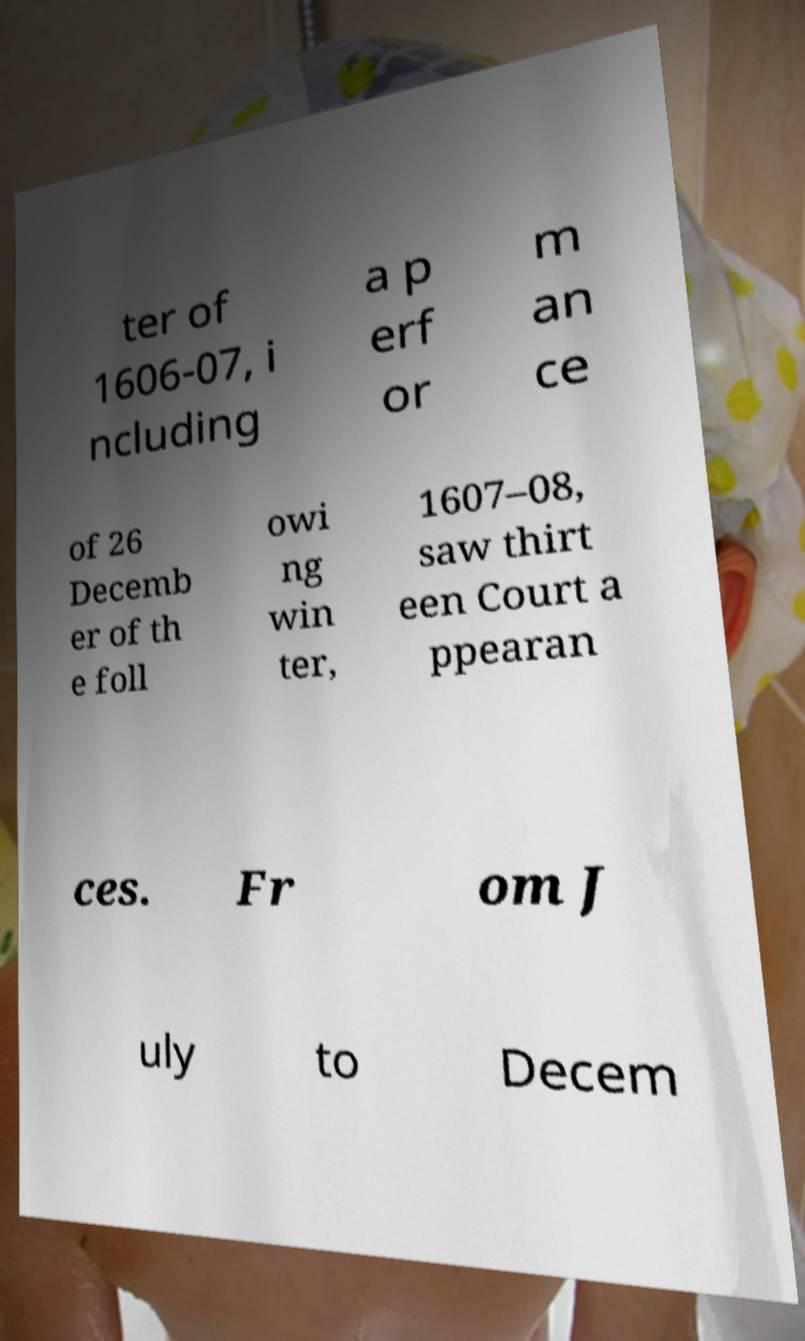For documentation purposes, I need the text within this image transcribed. Could you provide that? ter of 1606-07, i ncluding a p erf or m an ce of 26 Decemb er of th e foll owi ng win ter, 1607–08, saw thirt een Court a ppearan ces. Fr om J uly to Decem 